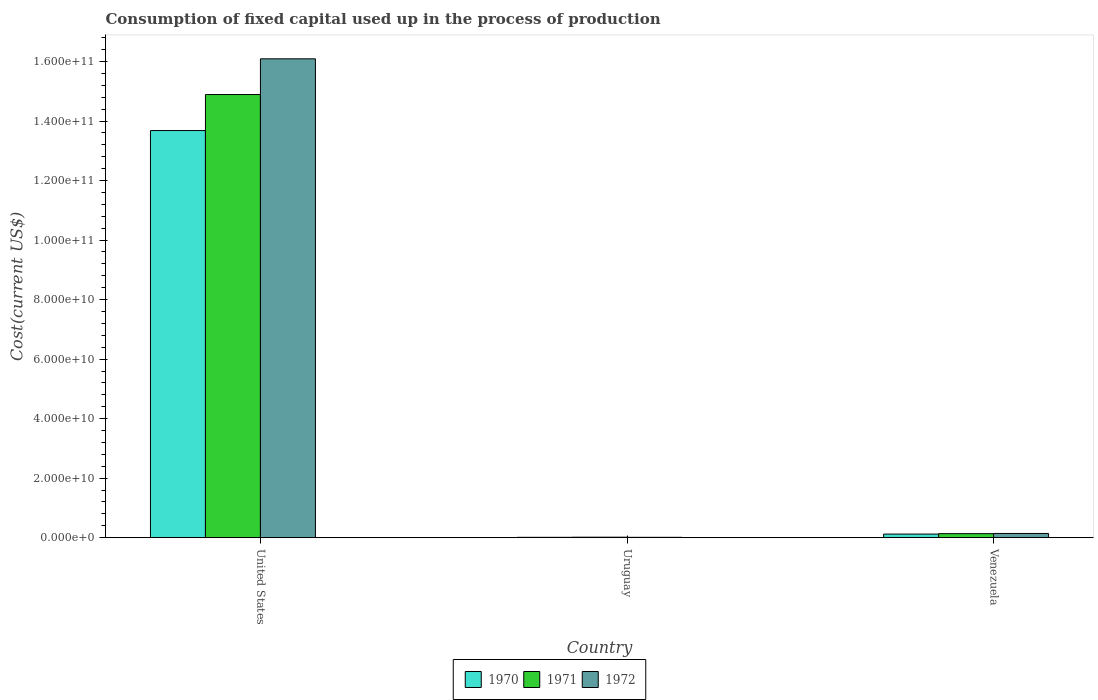How many different coloured bars are there?
Your answer should be compact. 3. How many groups of bars are there?
Offer a very short reply. 3. Are the number of bars per tick equal to the number of legend labels?
Ensure brevity in your answer.  Yes. How many bars are there on the 3rd tick from the left?
Offer a very short reply. 3. What is the label of the 2nd group of bars from the left?
Offer a very short reply. Uruguay. In how many cases, is the number of bars for a given country not equal to the number of legend labels?
Ensure brevity in your answer.  0. What is the amount consumed in the process of production in 1971 in Uruguay?
Offer a terse response. 1.75e+08. Across all countries, what is the maximum amount consumed in the process of production in 1971?
Offer a very short reply. 1.49e+11. Across all countries, what is the minimum amount consumed in the process of production in 1971?
Keep it short and to the point. 1.75e+08. In which country was the amount consumed in the process of production in 1972 minimum?
Ensure brevity in your answer.  Uruguay. What is the total amount consumed in the process of production in 1972 in the graph?
Offer a very short reply. 1.62e+11. What is the difference between the amount consumed in the process of production in 1970 in United States and that in Uruguay?
Your answer should be compact. 1.37e+11. What is the difference between the amount consumed in the process of production in 1970 in Venezuela and the amount consumed in the process of production in 1971 in Uruguay?
Your answer should be very brief. 1.05e+09. What is the average amount consumed in the process of production in 1970 per country?
Keep it short and to the point. 4.61e+1. What is the difference between the amount consumed in the process of production of/in 1970 and amount consumed in the process of production of/in 1971 in Venezuela?
Offer a terse response. -1.34e+08. What is the ratio of the amount consumed in the process of production in 1971 in United States to that in Uruguay?
Provide a succinct answer. 852.35. Is the amount consumed in the process of production in 1970 in Uruguay less than that in Venezuela?
Your response must be concise. Yes. Is the difference between the amount consumed in the process of production in 1970 in Uruguay and Venezuela greater than the difference between the amount consumed in the process of production in 1971 in Uruguay and Venezuela?
Provide a succinct answer. Yes. What is the difference between the highest and the second highest amount consumed in the process of production in 1972?
Your answer should be compact. -1.30e+09. What is the difference between the highest and the lowest amount consumed in the process of production in 1970?
Ensure brevity in your answer.  1.37e+11. Is the sum of the amount consumed in the process of production in 1972 in United States and Venezuela greater than the maximum amount consumed in the process of production in 1971 across all countries?
Provide a short and direct response. Yes. What does the 3rd bar from the right in United States represents?
Keep it short and to the point. 1970. Are all the bars in the graph horizontal?
Keep it short and to the point. No. Does the graph contain any zero values?
Keep it short and to the point. No. Does the graph contain grids?
Your answer should be compact. No. Where does the legend appear in the graph?
Offer a terse response. Bottom center. How many legend labels are there?
Give a very brief answer. 3. What is the title of the graph?
Offer a very short reply. Consumption of fixed capital used up in the process of production. Does "1989" appear as one of the legend labels in the graph?
Make the answer very short. No. What is the label or title of the Y-axis?
Provide a succinct answer. Cost(current US$). What is the Cost(current US$) in 1970 in United States?
Keep it short and to the point. 1.37e+11. What is the Cost(current US$) of 1971 in United States?
Make the answer very short. 1.49e+11. What is the Cost(current US$) of 1972 in United States?
Provide a short and direct response. 1.61e+11. What is the Cost(current US$) in 1970 in Uruguay?
Provide a short and direct response. 1.32e+08. What is the Cost(current US$) in 1971 in Uruguay?
Offer a very short reply. 1.75e+08. What is the Cost(current US$) in 1972 in Uruguay?
Provide a short and direct response. 1.29e+08. What is the Cost(current US$) of 1970 in Venezuela?
Provide a short and direct response. 1.22e+09. What is the Cost(current US$) of 1971 in Venezuela?
Your answer should be compact. 1.36e+09. What is the Cost(current US$) in 1972 in Venezuela?
Your response must be concise. 1.43e+09. Across all countries, what is the maximum Cost(current US$) of 1970?
Give a very brief answer. 1.37e+11. Across all countries, what is the maximum Cost(current US$) of 1971?
Keep it short and to the point. 1.49e+11. Across all countries, what is the maximum Cost(current US$) in 1972?
Your answer should be very brief. 1.61e+11. Across all countries, what is the minimum Cost(current US$) in 1970?
Provide a short and direct response. 1.32e+08. Across all countries, what is the minimum Cost(current US$) in 1971?
Your answer should be very brief. 1.75e+08. Across all countries, what is the minimum Cost(current US$) of 1972?
Ensure brevity in your answer.  1.29e+08. What is the total Cost(current US$) of 1970 in the graph?
Your answer should be compact. 1.38e+11. What is the total Cost(current US$) of 1971 in the graph?
Provide a succinct answer. 1.50e+11. What is the total Cost(current US$) in 1972 in the graph?
Your answer should be compact. 1.62e+11. What is the difference between the Cost(current US$) of 1970 in United States and that in Uruguay?
Keep it short and to the point. 1.37e+11. What is the difference between the Cost(current US$) of 1971 in United States and that in Uruguay?
Provide a short and direct response. 1.49e+11. What is the difference between the Cost(current US$) in 1972 in United States and that in Uruguay?
Keep it short and to the point. 1.61e+11. What is the difference between the Cost(current US$) of 1970 in United States and that in Venezuela?
Your answer should be very brief. 1.36e+11. What is the difference between the Cost(current US$) in 1971 in United States and that in Venezuela?
Offer a terse response. 1.48e+11. What is the difference between the Cost(current US$) of 1972 in United States and that in Venezuela?
Your response must be concise. 1.59e+11. What is the difference between the Cost(current US$) in 1970 in Uruguay and that in Venezuela?
Your answer should be compact. -1.09e+09. What is the difference between the Cost(current US$) in 1971 in Uruguay and that in Venezuela?
Provide a short and direct response. -1.18e+09. What is the difference between the Cost(current US$) of 1972 in Uruguay and that in Venezuela?
Provide a short and direct response. -1.30e+09. What is the difference between the Cost(current US$) of 1970 in United States and the Cost(current US$) of 1971 in Uruguay?
Offer a terse response. 1.37e+11. What is the difference between the Cost(current US$) of 1970 in United States and the Cost(current US$) of 1972 in Uruguay?
Your answer should be very brief. 1.37e+11. What is the difference between the Cost(current US$) in 1971 in United States and the Cost(current US$) in 1972 in Uruguay?
Provide a short and direct response. 1.49e+11. What is the difference between the Cost(current US$) of 1970 in United States and the Cost(current US$) of 1971 in Venezuela?
Ensure brevity in your answer.  1.35e+11. What is the difference between the Cost(current US$) of 1970 in United States and the Cost(current US$) of 1972 in Venezuela?
Offer a very short reply. 1.35e+11. What is the difference between the Cost(current US$) of 1971 in United States and the Cost(current US$) of 1972 in Venezuela?
Offer a terse response. 1.47e+11. What is the difference between the Cost(current US$) of 1970 in Uruguay and the Cost(current US$) of 1971 in Venezuela?
Give a very brief answer. -1.22e+09. What is the difference between the Cost(current US$) in 1970 in Uruguay and the Cost(current US$) in 1972 in Venezuela?
Provide a short and direct response. -1.30e+09. What is the difference between the Cost(current US$) of 1971 in Uruguay and the Cost(current US$) of 1972 in Venezuela?
Make the answer very short. -1.25e+09. What is the average Cost(current US$) of 1970 per country?
Provide a short and direct response. 4.61e+1. What is the average Cost(current US$) of 1971 per country?
Keep it short and to the point. 5.01e+1. What is the average Cost(current US$) in 1972 per country?
Provide a short and direct response. 5.42e+1. What is the difference between the Cost(current US$) in 1970 and Cost(current US$) in 1971 in United States?
Your answer should be compact. -1.21e+1. What is the difference between the Cost(current US$) in 1970 and Cost(current US$) in 1972 in United States?
Provide a short and direct response. -2.41e+1. What is the difference between the Cost(current US$) of 1971 and Cost(current US$) of 1972 in United States?
Your answer should be very brief. -1.20e+1. What is the difference between the Cost(current US$) of 1970 and Cost(current US$) of 1971 in Uruguay?
Your answer should be very brief. -4.22e+07. What is the difference between the Cost(current US$) in 1970 and Cost(current US$) in 1972 in Uruguay?
Your response must be concise. 3.35e+06. What is the difference between the Cost(current US$) in 1971 and Cost(current US$) in 1972 in Uruguay?
Offer a very short reply. 4.56e+07. What is the difference between the Cost(current US$) in 1970 and Cost(current US$) in 1971 in Venezuela?
Offer a terse response. -1.34e+08. What is the difference between the Cost(current US$) of 1970 and Cost(current US$) of 1972 in Venezuela?
Ensure brevity in your answer.  -2.06e+08. What is the difference between the Cost(current US$) of 1971 and Cost(current US$) of 1972 in Venezuela?
Keep it short and to the point. -7.19e+07. What is the ratio of the Cost(current US$) of 1970 in United States to that in Uruguay?
Offer a terse response. 1032.87. What is the ratio of the Cost(current US$) in 1971 in United States to that in Uruguay?
Make the answer very short. 852.35. What is the ratio of the Cost(current US$) of 1972 in United States to that in Uruguay?
Your answer should be compact. 1246.32. What is the ratio of the Cost(current US$) of 1970 in United States to that in Venezuela?
Make the answer very short. 111.88. What is the ratio of the Cost(current US$) of 1971 in United States to that in Venezuela?
Offer a very short reply. 109.71. What is the ratio of the Cost(current US$) of 1972 in United States to that in Venezuela?
Ensure brevity in your answer.  112.58. What is the ratio of the Cost(current US$) in 1970 in Uruguay to that in Venezuela?
Keep it short and to the point. 0.11. What is the ratio of the Cost(current US$) in 1971 in Uruguay to that in Venezuela?
Your answer should be very brief. 0.13. What is the ratio of the Cost(current US$) of 1972 in Uruguay to that in Venezuela?
Make the answer very short. 0.09. What is the difference between the highest and the second highest Cost(current US$) of 1970?
Provide a succinct answer. 1.36e+11. What is the difference between the highest and the second highest Cost(current US$) in 1971?
Ensure brevity in your answer.  1.48e+11. What is the difference between the highest and the second highest Cost(current US$) of 1972?
Provide a short and direct response. 1.59e+11. What is the difference between the highest and the lowest Cost(current US$) in 1970?
Your answer should be compact. 1.37e+11. What is the difference between the highest and the lowest Cost(current US$) in 1971?
Ensure brevity in your answer.  1.49e+11. What is the difference between the highest and the lowest Cost(current US$) of 1972?
Provide a short and direct response. 1.61e+11. 